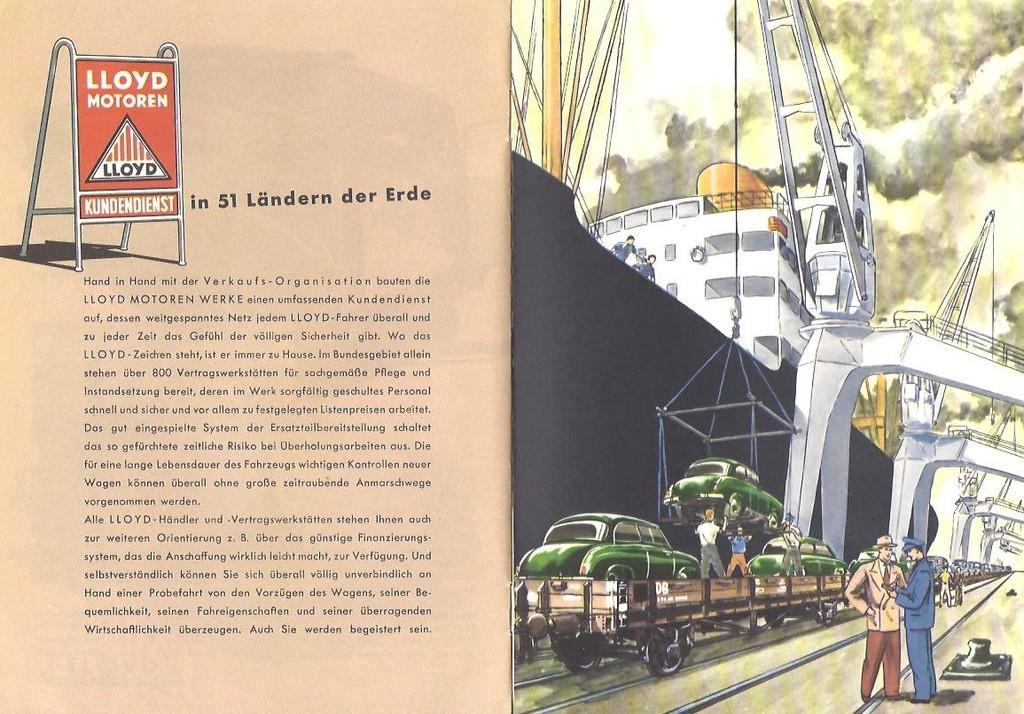Could you give a brief overview of what you see in this image? This is an image of the article and painting on the right, where we can see there is article on the left and also there is a painting of cars putting in the goods train and beside that there are few people standing. 